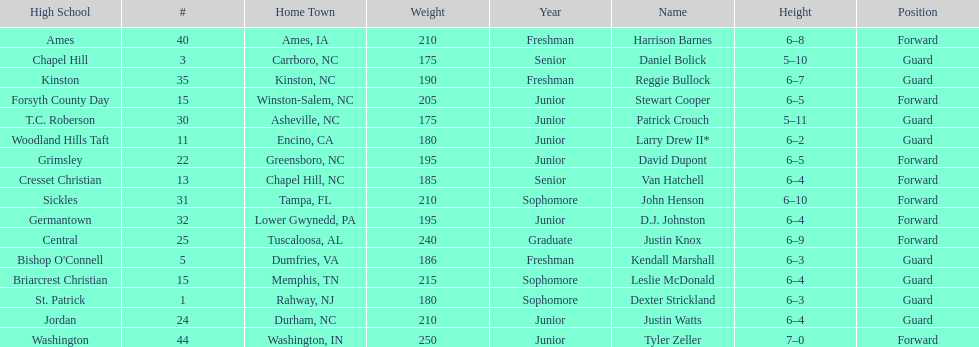What is the number of players with a weight over 200? 7. 